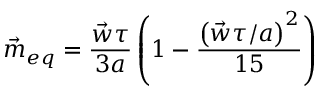Convert formula to latex. <formula><loc_0><loc_0><loc_500><loc_500>\vec { m } _ { e q } = \frac { \vec { w } \tau } { 3 a } \left ( 1 - \frac { \left ( \vec { w } \tau / a \right ) ^ { 2 } } { 1 5 } \right )</formula> 